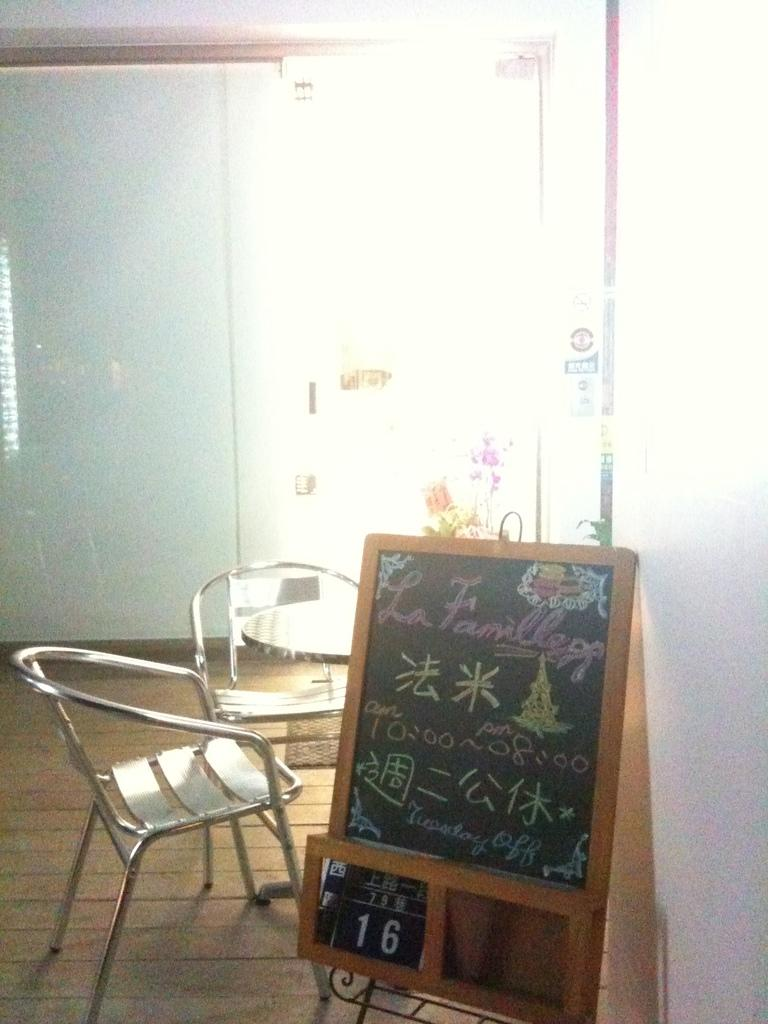What color is the floor in the image? The floor in the image is brown. How many chairs are in the image? There are two chairs in the image. What other furniture is present in the image? There is a table in the image. Can you describe the board in the image? The board in the image is brown and black in color. What can be seen in the background of the image? The background of the image includes a wall and the ceiling. How many pencils are on the table in the image? There is no mention of pencils in the image; only a board, chairs, and a table are present. What type of heat source is used in the image? There is no heat source visible in the image. 